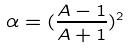Convert formula to latex. <formula><loc_0><loc_0><loc_500><loc_500>\alpha = ( \frac { A - 1 } { A + 1 } ) ^ { 2 }</formula> 